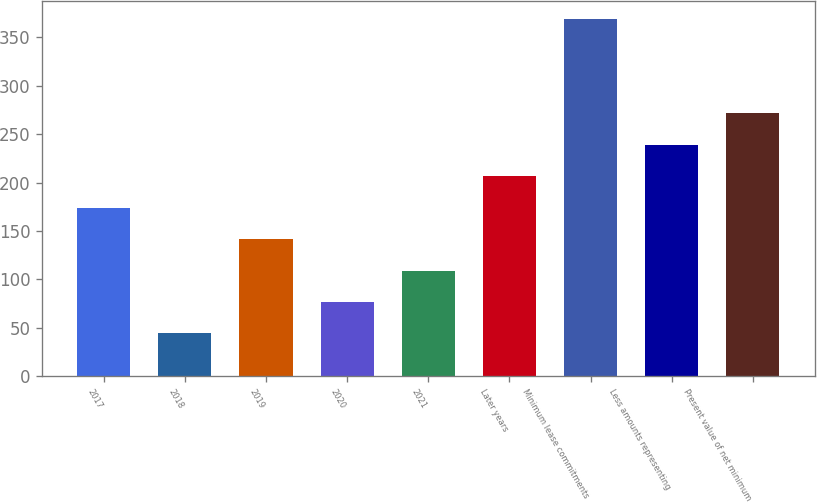<chart> <loc_0><loc_0><loc_500><loc_500><bar_chart><fcel>2017<fcel>2018<fcel>2019<fcel>2020<fcel>2021<fcel>Later years<fcel>Minimum lease commitments<fcel>Less amounts representing<fcel>Present value of net minimum<nl><fcel>174<fcel>44<fcel>141.5<fcel>76.5<fcel>109<fcel>206.5<fcel>369<fcel>239<fcel>271.5<nl></chart> 